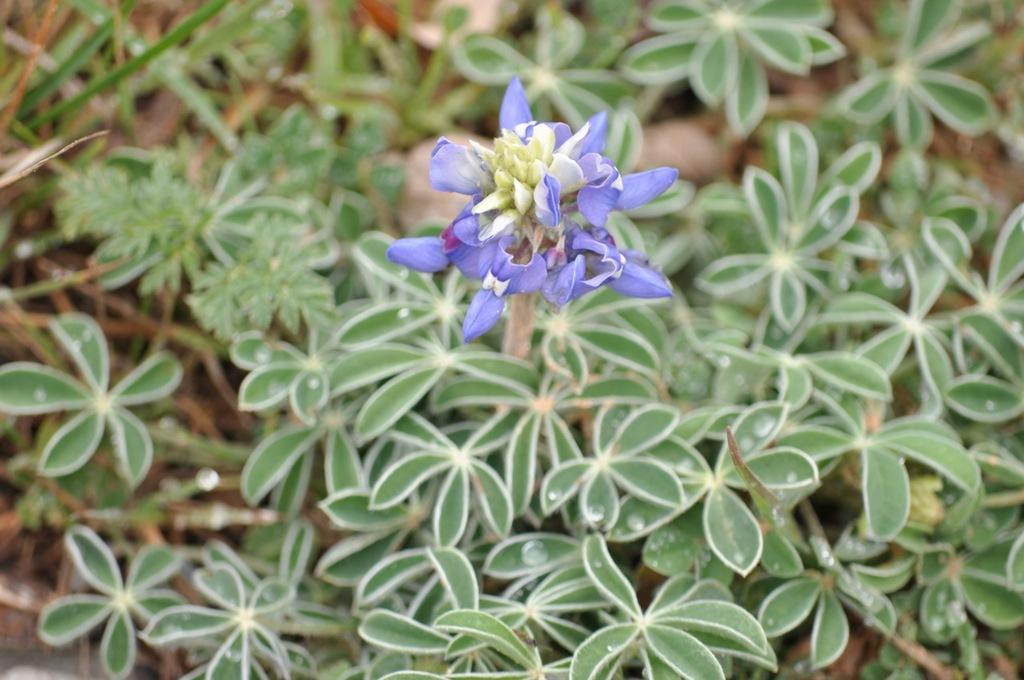What type of flowers can be seen in the image? There are purple flowers in the image. To which plant do the flowers belong? The flowers belong to a plant. How many plants are visible on the land in the image? There are many plants on the land in the image. What is the process of digestion like for the flowers in the image? The flowers in the image do not have a digestive system, as they are not living organisms capable of digestion. 